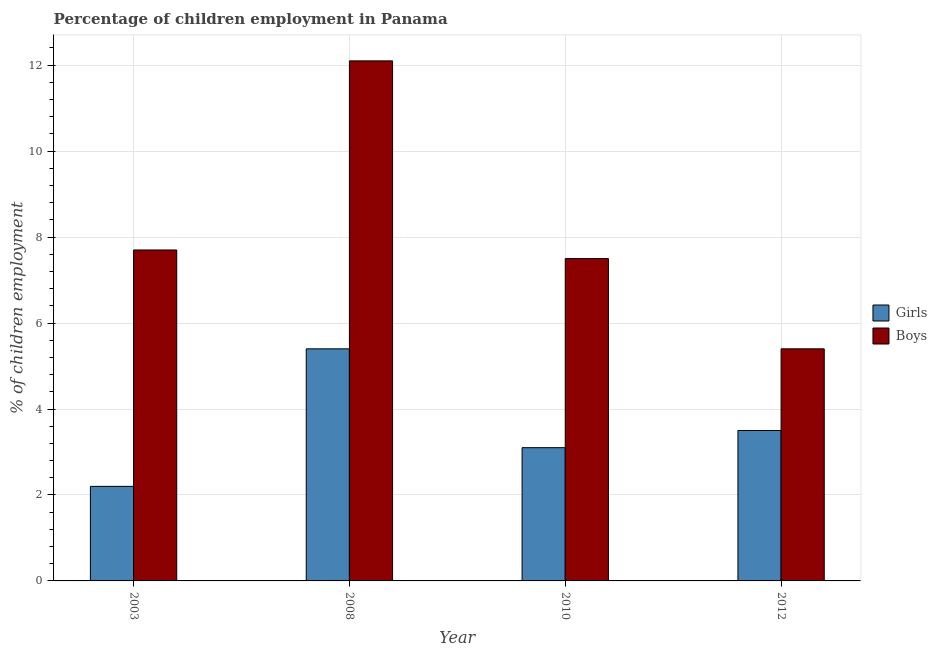How many different coloured bars are there?
Offer a very short reply. 2. What is the label of the 4th group of bars from the left?
Keep it short and to the point. 2012. In how many cases, is the number of bars for a given year not equal to the number of legend labels?
Ensure brevity in your answer.  0. Across all years, what is the maximum percentage of employed girls?
Your answer should be compact. 5.4. In which year was the percentage of employed boys maximum?
Ensure brevity in your answer.  2008. What is the total percentage of employed boys in the graph?
Your response must be concise. 32.7. What is the difference between the percentage of employed boys in 2003 and that in 2010?
Give a very brief answer. 0.2. What is the average percentage of employed girls per year?
Make the answer very short. 3.55. In how many years, is the percentage of employed girls greater than 4 %?
Your response must be concise. 1. What is the ratio of the percentage of employed girls in 2003 to that in 2012?
Keep it short and to the point. 0.63. Is the percentage of employed boys in 2010 less than that in 2012?
Give a very brief answer. No. What is the difference between the highest and the second highest percentage of employed girls?
Provide a succinct answer. 1.9. What is the difference between the highest and the lowest percentage of employed boys?
Offer a terse response. 6.7. In how many years, is the percentage of employed girls greater than the average percentage of employed girls taken over all years?
Your answer should be very brief. 1. Is the sum of the percentage of employed boys in 2003 and 2008 greater than the maximum percentage of employed girls across all years?
Provide a short and direct response. Yes. What does the 2nd bar from the left in 2008 represents?
Offer a very short reply. Boys. What does the 2nd bar from the right in 2003 represents?
Provide a succinct answer. Girls. How many bars are there?
Give a very brief answer. 8. Are all the bars in the graph horizontal?
Offer a terse response. No. What is the difference between two consecutive major ticks on the Y-axis?
Keep it short and to the point. 2. Does the graph contain any zero values?
Offer a terse response. No. Does the graph contain grids?
Keep it short and to the point. Yes. What is the title of the graph?
Keep it short and to the point. Percentage of children employment in Panama. What is the label or title of the Y-axis?
Your answer should be compact. % of children employment. What is the % of children employment of Girls in 2008?
Offer a very short reply. 5.4. What is the % of children employment in Boys in 2008?
Ensure brevity in your answer.  12.1. What is the % of children employment of Girls in 2010?
Offer a very short reply. 3.1. What is the % of children employment of Boys in 2010?
Ensure brevity in your answer.  7.5. What is the % of children employment of Girls in 2012?
Provide a succinct answer. 3.5. What is the % of children employment of Boys in 2012?
Your answer should be very brief. 5.4. Across all years, what is the maximum % of children employment in Girls?
Offer a terse response. 5.4. Across all years, what is the minimum % of children employment of Boys?
Your answer should be very brief. 5.4. What is the total % of children employment of Boys in the graph?
Give a very brief answer. 32.7. What is the difference between the % of children employment in Girls in 2003 and that in 2010?
Make the answer very short. -0.9. What is the difference between the % of children employment of Girls in 2003 and that in 2012?
Give a very brief answer. -1.3. What is the difference between the % of children employment of Boys in 2003 and that in 2012?
Keep it short and to the point. 2.3. What is the difference between the % of children employment in Girls in 2008 and that in 2012?
Offer a very short reply. 1.9. What is the difference between the % of children employment of Girls in 2003 and the % of children employment of Boys in 2010?
Ensure brevity in your answer.  -5.3. What is the average % of children employment of Girls per year?
Keep it short and to the point. 3.55. What is the average % of children employment of Boys per year?
Offer a terse response. 8.18. In the year 2003, what is the difference between the % of children employment of Girls and % of children employment of Boys?
Your response must be concise. -5.5. In the year 2008, what is the difference between the % of children employment in Girls and % of children employment in Boys?
Your answer should be very brief. -6.7. What is the ratio of the % of children employment of Girls in 2003 to that in 2008?
Provide a short and direct response. 0.41. What is the ratio of the % of children employment in Boys in 2003 to that in 2008?
Provide a short and direct response. 0.64. What is the ratio of the % of children employment in Girls in 2003 to that in 2010?
Ensure brevity in your answer.  0.71. What is the ratio of the % of children employment of Boys in 2003 to that in 2010?
Give a very brief answer. 1.03. What is the ratio of the % of children employment in Girls in 2003 to that in 2012?
Keep it short and to the point. 0.63. What is the ratio of the % of children employment of Boys in 2003 to that in 2012?
Provide a succinct answer. 1.43. What is the ratio of the % of children employment of Girls in 2008 to that in 2010?
Give a very brief answer. 1.74. What is the ratio of the % of children employment of Boys in 2008 to that in 2010?
Your answer should be very brief. 1.61. What is the ratio of the % of children employment in Girls in 2008 to that in 2012?
Your response must be concise. 1.54. What is the ratio of the % of children employment of Boys in 2008 to that in 2012?
Offer a terse response. 2.24. What is the ratio of the % of children employment in Girls in 2010 to that in 2012?
Ensure brevity in your answer.  0.89. What is the ratio of the % of children employment in Boys in 2010 to that in 2012?
Offer a very short reply. 1.39. What is the difference between the highest and the second highest % of children employment in Boys?
Your answer should be compact. 4.4. What is the difference between the highest and the lowest % of children employment in Boys?
Offer a very short reply. 6.7. 